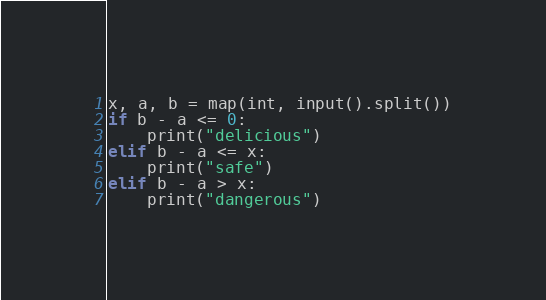Convert code to text. <code><loc_0><loc_0><loc_500><loc_500><_Python_>x, a, b = map(int, input().split())
if b - a <= 0:
    print("delicious")
elif b - a <= x:
    print("safe")
elif b - a > x:
    print("dangerous")
</code> 